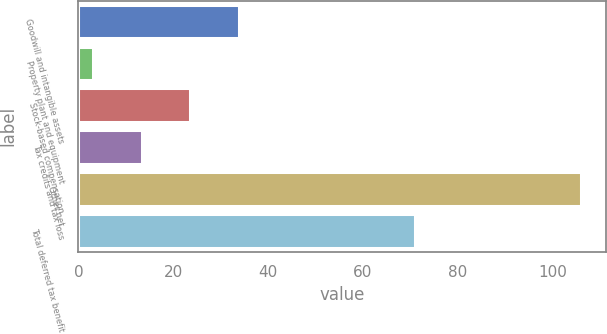Convert chart. <chart><loc_0><loc_0><loc_500><loc_500><bar_chart><fcel>Goodwill and intangible assets<fcel>Property plant and equipment<fcel>Stock-based compensation<fcel>Tax credits and tax loss<fcel>Other net<fcel>Total deferred tax benefit<nl><fcel>33.9<fcel>3<fcel>23.6<fcel>13.3<fcel>106<fcel>71<nl></chart> 